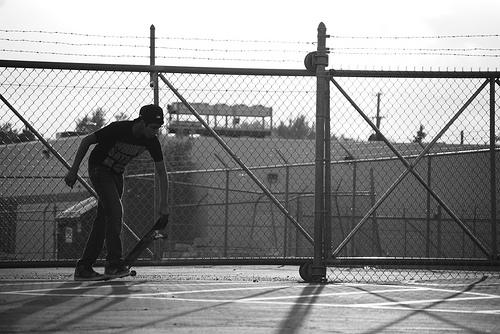What is the primary object that the boy is interacting with, and what is he doing? The boy is interacting with a skateboard, performing a skateboarding trick by flipping it up. What is the color of the shirt the young man is wearing and what's written on it? The young man is wearing a black shirt with words on it. How is the young man's hat positioned, and what color is it? The young man's hat is positioned backwards and it is black in color. Mention the type of fence shown in the image and what's on top of it. It's a chain link fence with three rows of barbed wire on top. Explain the atmospheric condition in the image. The image shows a gray sky, indicating overcast or cloudy weather. List three main objects or features found on the ground in the image. Black top surface, white striped lines, and shadow of the fence. In the background of the image, what type of building and trees can be seen? white building and top of trees What type of lines are painted on the ground? white striped lines Write a caption for this image, showcasing the man's actions. young man is skateboarding, performing a trick with a tipped up black skateboard How does the man have his hat? baseball hat on backwards What is the color of the skateboard in the image? black Can you see a blue baseball cap worn forwards on the man's head? The man is wearing a black baseball cap, not a blue one, and it is worn backward, not forwards. Is the boy performing a skateboarding trick while wearing a red shirt? In the image, the boy is actually wearing a dark shirt, not a red shirt. What activity is the man doing with his skateboard? performing a skateboarding trick Describe the wheel seen in the picture. wheel on a fence Which of the following best describes the man's shoes: high tops, skate shoes, or sandals? skate shoes Is the man wearing jeans or shorts? jeans Look at the man's shirt and describe what it has on it. words What is the position of the skateboard in the image? tipped up Is there a black cap on a man? If so, what angle is it on? Yes, on backwards Is the man wearing a plain black shirt or one with words on it? black shirt with words Identify the fencing material used in the picture. chain link fence Is there a circular iron gate around the white building in the back? The gate around the building is actually a chain link fence, not a circular iron gate. Are there six rows of barbed wire on top of the fence? There are only three rows of barbed wire on top of the fence, not six. What type of hat is the man wearing? black baseball cap What type of sky is present in the image? gray sky Is the sky in the image bright and sunny? The sky in the image is actually gray, not bright and sunny. How many rows of barbed wire are on top of the fence? three How is the fencing support structure designed? support beams make an x shape Are the shoes on the man's feet low tops? The shoes on the man's feet are high tops, not low tops. What is behind the man and the fence in the image? dumpster 